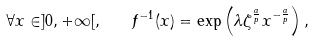<formula> <loc_0><loc_0><loc_500><loc_500>\forall x \in ] 0 , + \infty [ , \quad f ^ { - 1 } ( x ) = \exp \left ( \lambda \zeta ^ { \frac { a } { p } } x ^ { - \frac { a } { p } } \right ) ,</formula> 